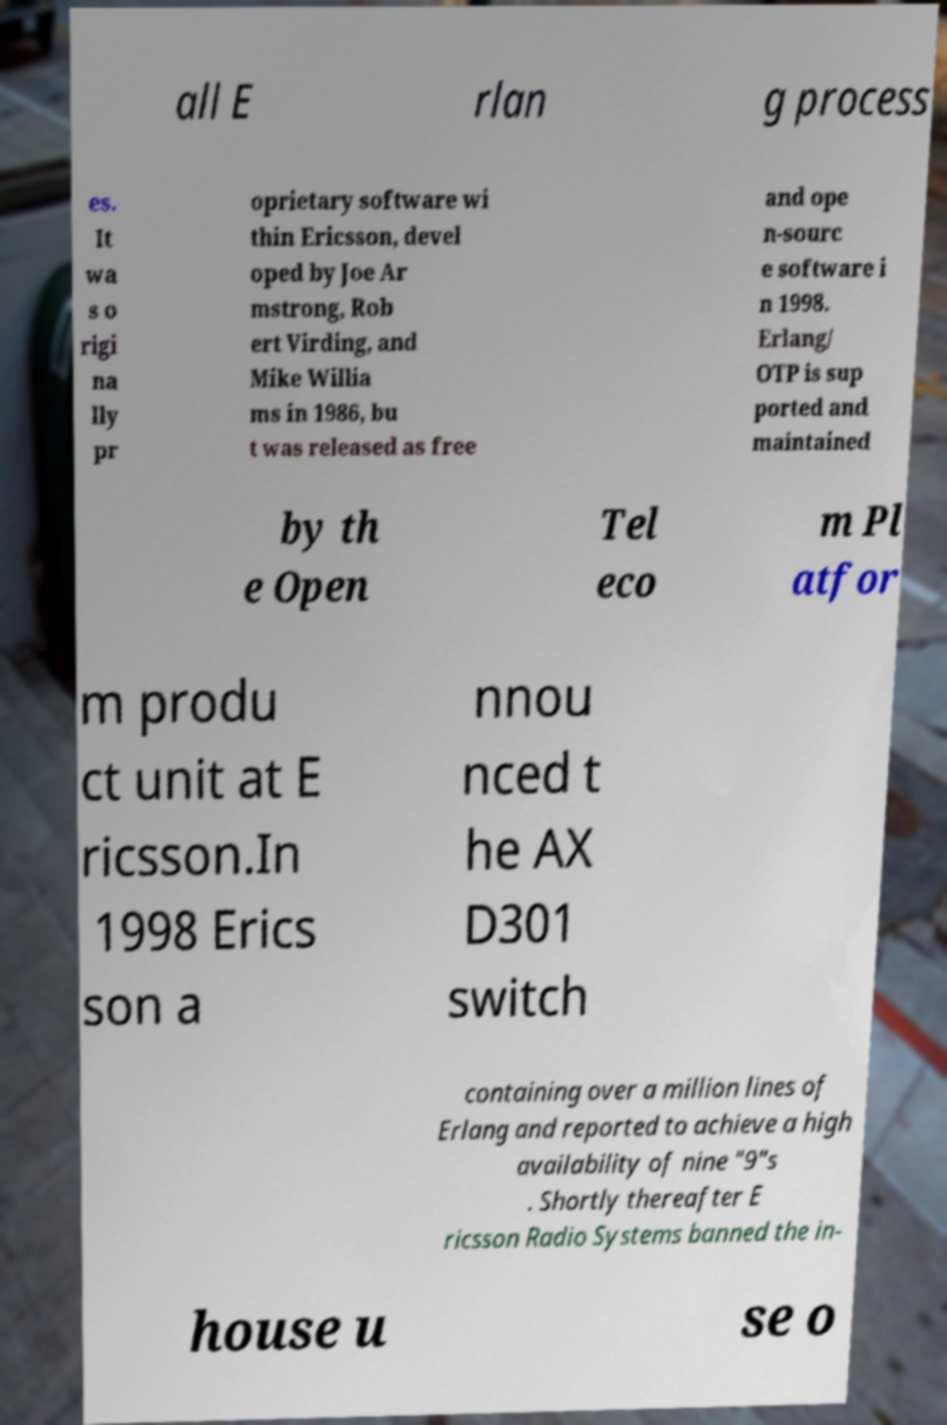Please identify and transcribe the text found in this image. all E rlan g process es. It wa s o rigi na lly pr oprietary software wi thin Ericsson, devel oped by Joe Ar mstrong, Rob ert Virding, and Mike Willia ms in 1986, bu t was released as free and ope n-sourc e software i n 1998. Erlang/ OTP is sup ported and maintained by th e Open Tel eco m Pl atfor m produ ct unit at E ricsson.In 1998 Erics son a nnou nced t he AX D301 switch containing over a million lines of Erlang and reported to achieve a high availability of nine "9"s . Shortly thereafter E ricsson Radio Systems banned the in- house u se o 